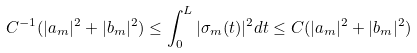<formula> <loc_0><loc_0><loc_500><loc_500>C ^ { - 1 } ( | a _ { m } | ^ { 2 } + | b _ { m } | ^ { 2 } ) \leq \int _ { 0 } ^ { L } | \sigma _ { m } ( t ) | ^ { 2 } d t \leq C ( | a _ { m } | ^ { 2 } + | b _ { m } | ^ { 2 } )</formula> 